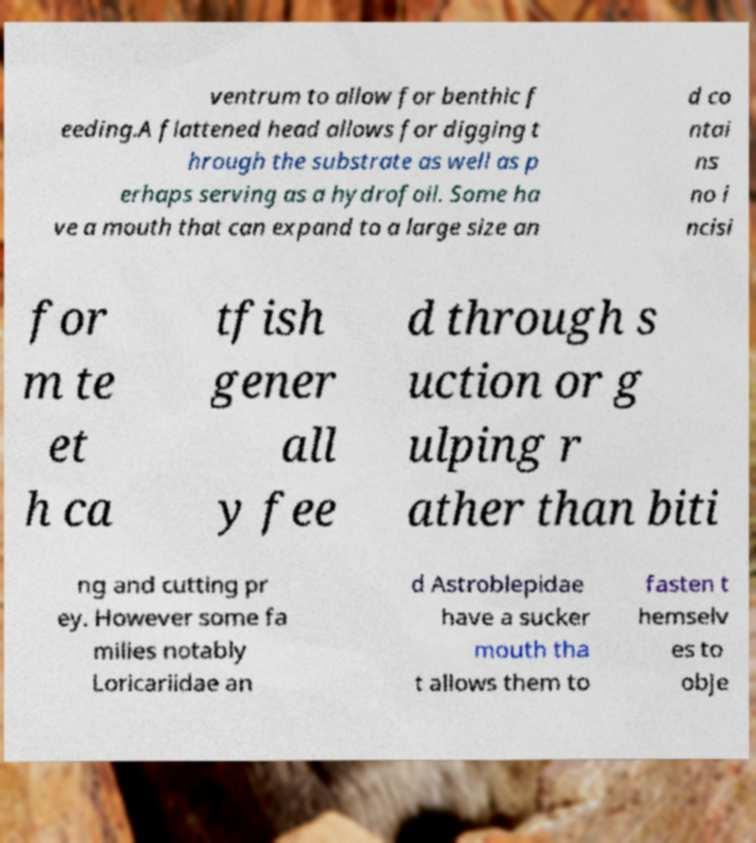Can you read and provide the text displayed in the image?This photo seems to have some interesting text. Can you extract and type it out for me? ventrum to allow for benthic f eeding.A flattened head allows for digging t hrough the substrate as well as p erhaps serving as a hydrofoil. Some ha ve a mouth that can expand to a large size an d co ntai ns no i ncisi for m te et h ca tfish gener all y fee d through s uction or g ulping r ather than biti ng and cutting pr ey. However some fa milies notably Loricariidae an d Astroblepidae have a sucker mouth tha t allows them to fasten t hemselv es to obje 